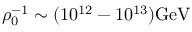Convert formula to latex. <formula><loc_0><loc_0><loc_500><loc_500>\rho _ { 0 } ^ { - 1 } \sim ( 1 0 ^ { 1 2 } - 1 0 ^ { 1 3 } ) G e V</formula> 